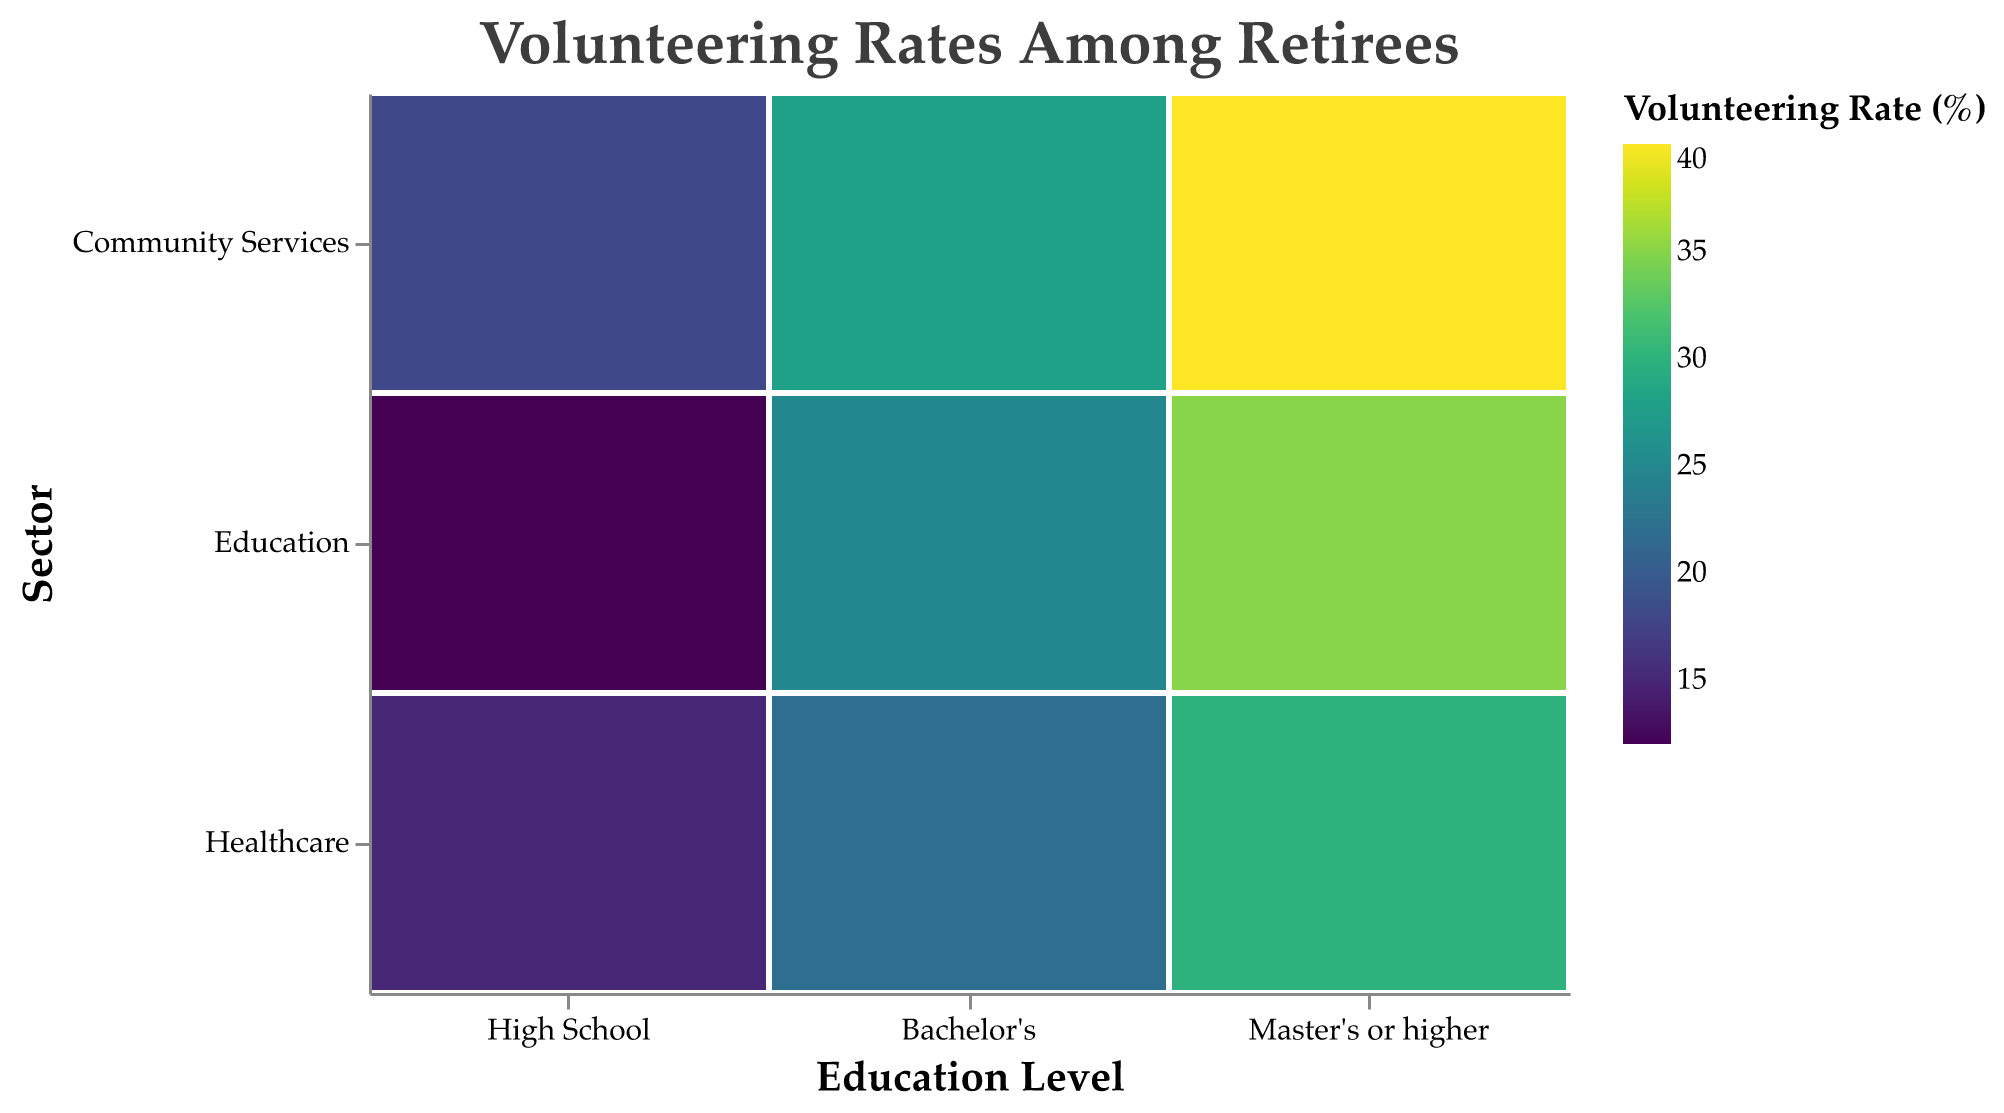What is the volunteering rate for retirees with a Master's degree or higher in the Community Services sector? Look for the cell corresponding to "Master's or higher" education level and "Community Services" sector, then check the value
Answer: 40% Which education level has the highest volunteering rate in the Healthcare sector? Compare the volunteering rates for "Healthcare" across different education levels: High School (15%), Bachelor's (22%), Master's or higher (30%)
Answer: Master's or higher What is the difference in volunteering rates between retirees with Bachelor's degrees in the Education and Healthcare sectors? Find the volunteering rates for Bachelor's in Education (25%) and Healthcare (22%) and calculate the difference: 25% - 22%
Answer: 3% How does the volunteering rate for retirees with a High School education in the Community Services sector compare to those with a Bachelor's degree in the same sector? Compare the rates: High School (18%) vs. Bachelor's (28%). Notice that 28% is greater than 18%
Answer: Bachelor's degree has a higher rate What is the average volunteering rate for retirees with a High School education across all sectors? Sum the volunteering rates for High School across all sectors: (15 + 12 + 18) = 45, then divide by 3 (number of sectors)
Answer: 15% Which sector has the highest overall volunteering rate across all education levels? Observe the color intensities and the actual numbers, and identify the highest volunteering rate: Community Services at Master's or higher (40%)
Answer: Community Services What is the ratio of volunteering rates between retirees with Master's or higher degrees and High School education in the Education sector? Find the rates for Master's or higher in Education (35%) and High School in Education (12%), then calculate the ratio: 35 / 12
Answer: 35:12 or approx. 2.92 Is there a noticeable trend in volunteering rates as the education level increases within the same sector? Observe each sector's volunteering rates as education level changes, note the increasing trend in all sectors (Healthcare, Education, Community Services)
Answer: Yes What is the total volunteering rate percentage for retirees with a Bachelor's degree across all sectors? Sum the volunteering rates for Bachelor's across all sectors: 22 + 25 + 28 = 75
Answer: 75% Do retirees with higher education levels generally volunteer more across all sectors? Compare the volunteering rates for each education level across sectors: higher education levels consistently have higher rates.
Answer: Yes Which education level sees the highest increase in volunteering rate when moving from High School to Bachelor's in the Community Services sector? Compare the rates: High School (18%) and Bachelor's (28%) in Community Services, difference is 28% - 18%
Answer: 10% increase with Bachelor's 